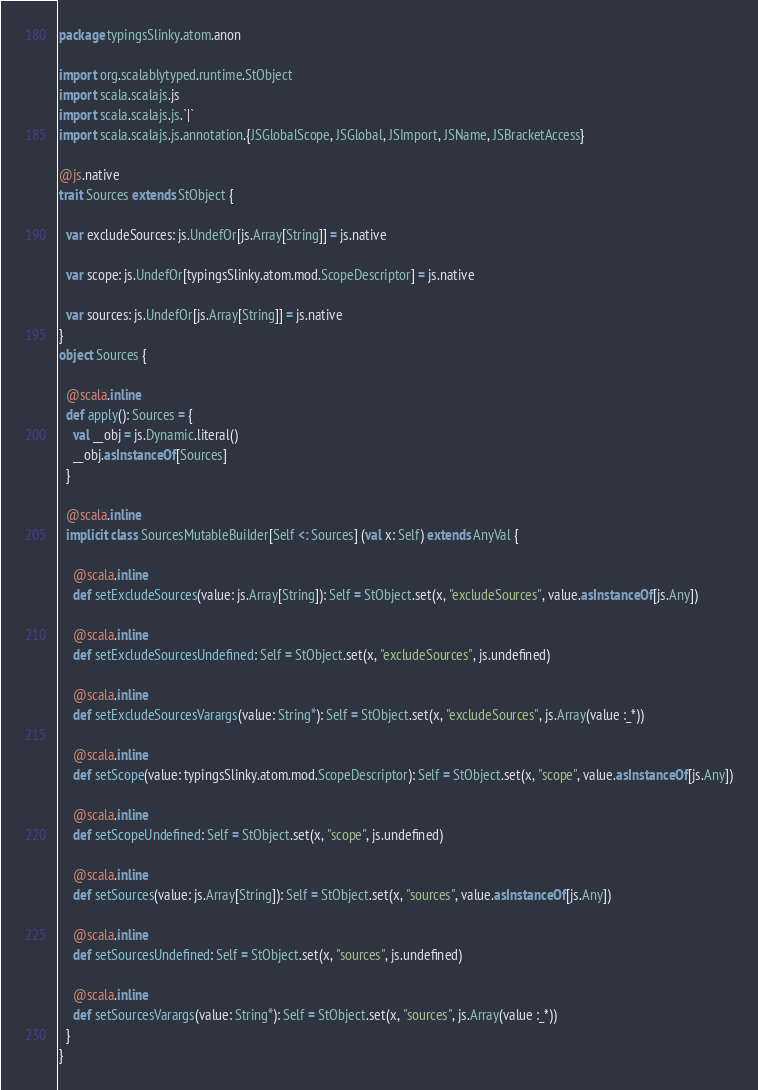<code> <loc_0><loc_0><loc_500><loc_500><_Scala_>package typingsSlinky.atom.anon

import org.scalablytyped.runtime.StObject
import scala.scalajs.js
import scala.scalajs.js.`|`
import scala.scalajs.js.annotation.{JSGlobalScope, JSGlobal, JSImport, JSName, JSBracketAccess}

@js.native
trait Sources extends StObject {
  
  var excludeSources: js.UndefOr[js.Array[String]] = js.native
  
  var scope: js.UndefOr[typingsSlinky.atom.mod.ScopeDescriptor] = js.native
  
  var sources: js.UndefOr[js.Array[String]] = js.native
}
object Sources {
  
  @scala.inline
  def apply(): Sources = {
    val __obj = js.Dynamic.literal()
    __obj.asInstanceOf[Sources]
  }
  
  @scala.inline
  implicit class SourcesMutableBuilder[Self <: Sources] (val x: Self) extends AnyVal {
    
    @scala.inline
    def setExcludeSources(value: js.Array[String]): Self = StObject.set(x, "excludeSources", value.asInstanceOf[js.Any])
    
    @scala.inline
    def setExcludeSourcesUndefined: Self = StObject.set(x, "excludeSources", js.undefined)
    
    @scala.inline
    def setExcludeSourcesVarargs(value: String*): Self = StObject.set(x, "excludeSources", js.Array(value :_*))
    
    @scala.inline
    def setScope(value: typingsSlinky.atom.mod.ScopeDescriptor): Self = StObject.set(x, "scope", value.asInstanceOf[js.Any])
    
    @scala.inline
    def setScopeUndefined: Self = StObject.set(x, "scope", js.undefined)
    
    @scala.inline
    def setSources(value: js.Array[String]): Self = StObject.set(x, "sources", value.asInstanceOf[js.Any])
    
    @scala.inline
    def setSourcesUndefined: Self = StObject.set(x, "sources", js.undefined)
    
    @scala.inline
    def setSourcesVarargs(value: String*): Self = StObject.set(x, "sources", js.Array(value :_*))
  }
}
</code> 